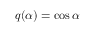Convert formula to latex. <formula><loc_0><loc_0><loc_500><loc_500>q ( \alpha ) = \cos { \alpha }</formula> 